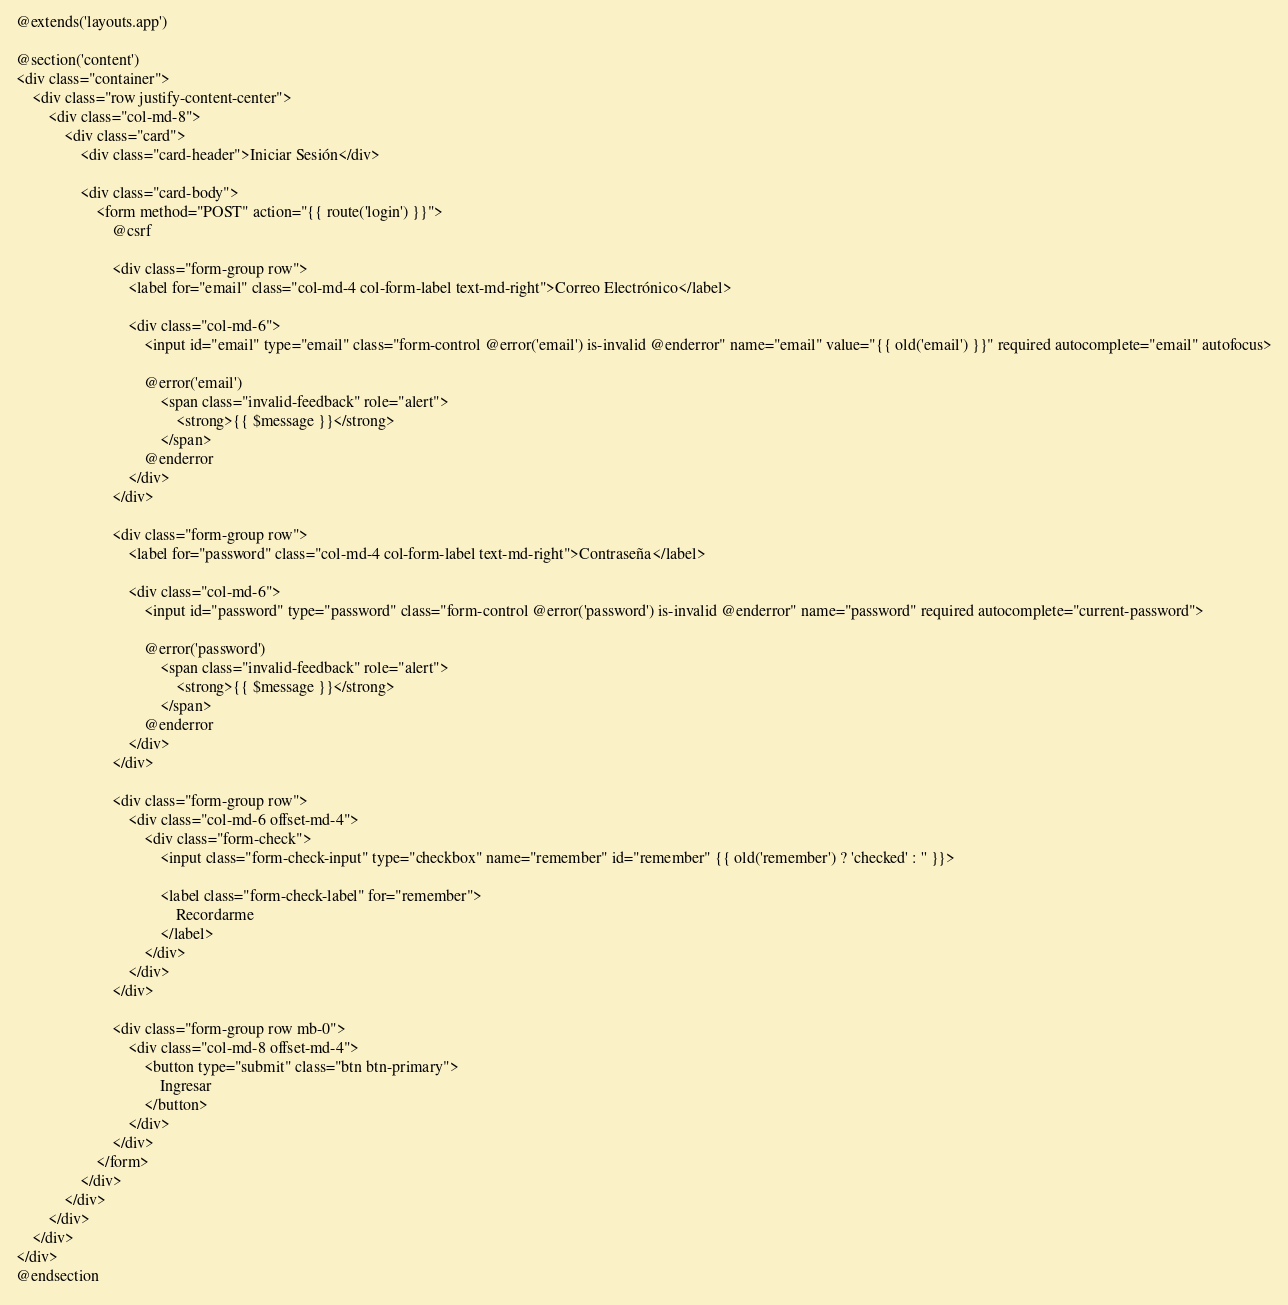<code> <loc_0><loc_0><loc_500><loc_500><_PHP_>@extends('layouts.app')

@section('content')
<div class="container">
    <div class="row justify-content-center">
        <div class="col-md-8">
            <div class="card">
                <div class="card-header">Iniciar Sesión</div>

                <div class="card-body">
                    <form method="POST" action="{{ route('login') }}">
                        @csrf

                        <div class="form-group row">
                            <label for="email" class="col-md-4 col-form-label text-md-right">Correo Electrónico</label>

                            <div class="col-md-6">
                                <input id="email" type="email" class="form-control @error('email') is-invalid @enderror" name="email" value="{{ old('email') }}" required autocomplete="email" autofocus>

                                @error('email')
                                    <span class="invalid-feedback" role="alert">
                                        <strong>{{ $message }}</strong>
                                    </span>
                                @enderror
                            </div>
                        </div>

                        <div class="form-group row">
                            <label for="password" class="col-md-4 col-form-label text-md-right">Contraseña</label>

                            <div class="col-md-6">
                                <input id="password" type="password" class="form-control @error('password') is-invalid @enderror" name="password" required autocomplete="current-password">

                                @error('password')
                                    <span class="invalid-feedback" role="alert">
                                        <strong>{{ $message }}</strong>
                                    </span>
                                @enderror
                            </div>
                        </div>

                        <div class="form-group row">
                            <div class="col-md-6 offset-md-4">
                                <div class="form-check">
                                    <input class="form-check-input" type="checkbox" name="remember" id="remember" {{ old('remember') ? 'checked' : '' }}>

                                    <label class="form-check-label" for="remember">
                                        Recordarme
                                    </label>
                                </div>
                            </div>
                        </div>

                        <div class="form-group row mb-0">
                            <div class="col-md-8 offset-md-4">
                                <button type="submit" class="btn btn-primary">
                                    Ingresar
                                </button>
                            </div>
                        </div>
                    </form>
                </div>
            </div>
        </div>
    </div>
</div>
@endsection
</code> 